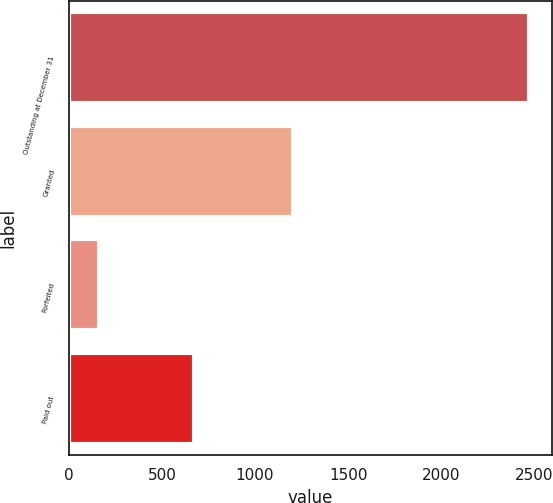<chart> <loc_0><loc_0><loc_500><loc_500><bar_chart><fcel>Outstanding at December 31<fcel>Granted<fcel>Forfeited<fcel>Paid out<nl><fcel>2469.9<fcel>1203<fcel>161<fcel>673<nl></chart> 